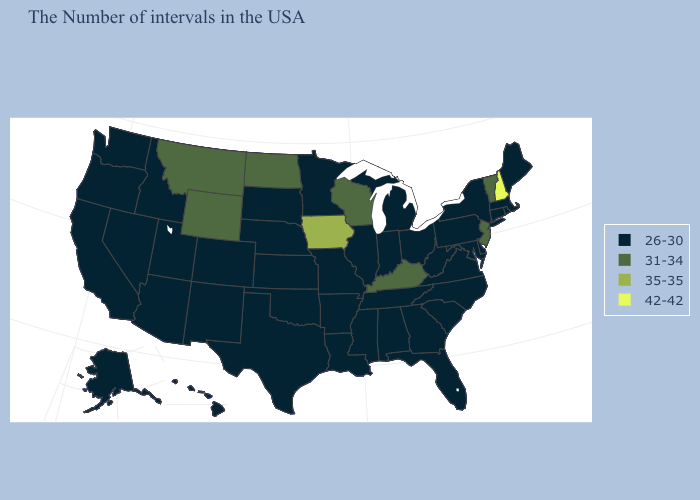Name the states that have a value in the range 31-34?
Be succinct. Vermont, New Jersey, Kentucky, Wisconsin, North Dakota, Wyoming, Montana. What is the highest value in the South ?
Answer briefly. 31-34. What is the value of Louisiana?
Be succinct. 26-30. Which states have the lowest value in the Northeast?
Quick response, please. Maine, Massachusetts, Rhode Island, Connecticut, New York, Pennsylvania. Name the states that have a value in the range 26-30?
Answer briefly. Maine, Massachusetts, Rhode Island, Connecticut, New York, Delaware, Maryland, Pennsylvania, Virginia, North Carolina, South Carolina, West Virginia, Ohio, Florida, Georgia, Michigan, Indiana, Alabama, Tennessee, Illinois, Mississippi, Louisiana, Missouri, Arkansas, Minnesota, Kansas, Nebraska, Oklahoma, Texas, South Dakota, Colorado, New Mexico, Utah, Arizona, Idaho, Nevada, California, Washington, Oregon, Alaska, Hawaii. Name the states that have a value in the range 31-34?
Short answer required. Vermont, New Jersey, Kentucky, Wisconsin, North Dakota, Wyoming, Montana. What is the highest value in the Northeast ?
Write a very short answer. 42-42. What is the highest value in states that border New Mexico?
Concise answer only. 26-30. Does Oregon have the highest value in the USA?
Be succinct. No. Name the states that have a value in the range 35-35?
Be succinct. Iowa. What is the value of South Carolina?
Answer briefly. 26-30. What is the value of West Virginia?
Concise answer only. 26-30. Which states hav the highest value in the West?
Answer briefly. Wyoming, Montana. Does Mississippi have the highest value in the USA?
Keep it brief. No. 